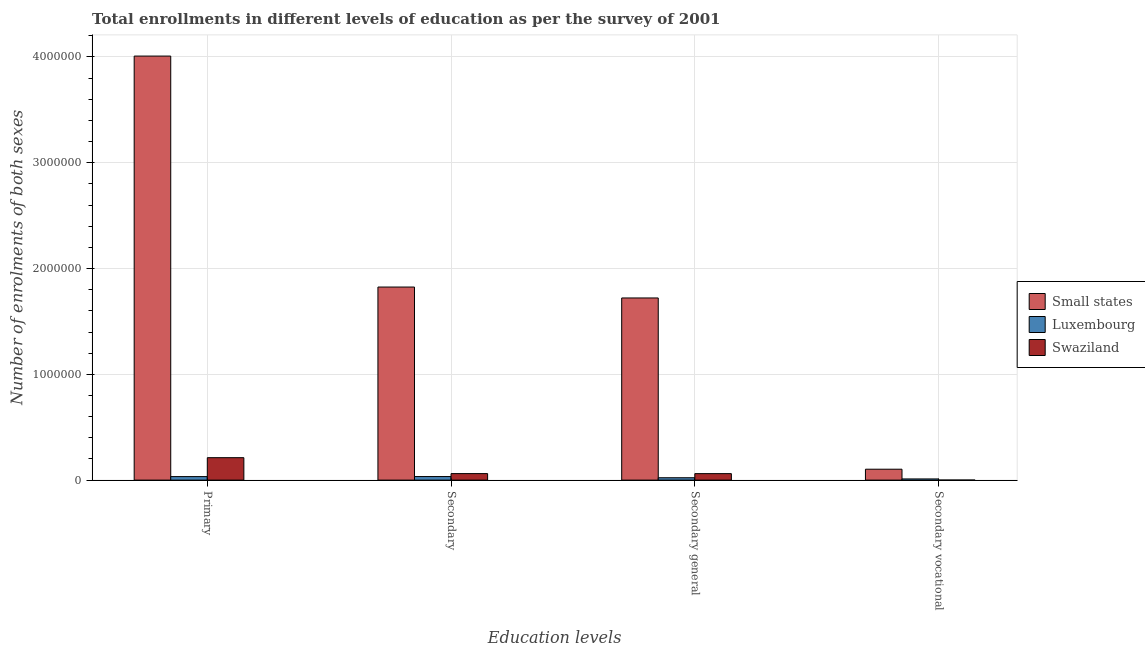How many different coloured bars are there?
Your response must be concise. 3. How many groups of bars are there?
Ensure brevity in your answer.  4. What is the label of the 4th group of bars from the left?
Your answer should be compact. Secondary vocational. What is the number of enrolments in secondary education in Small states?
Provide a succinct answer. 1.83e+06. Across all countries, what is the maximum number of enrolments in secondary education?
Offer a terse response. 1.83e+06. Across all countries, what is the minimum number of enrolments in secondary vocational education?
Offer a very short reply. 348. In which country was the number of enrolments in secondary education maximum?
Make the answer very short. Small states. In which country was the number of enrolments in secondary vocational education minimum?
Your response must be concise. Swaziland. What is the total number of enrolments in secondary education in the graph?
Provide a succinct answer. 1.92e+06. What is the difference between the number of enrolments in secondary education in Small states and that in Swaziland?
Your answer should be compact. 1.76e+06. What is the difference between the number of enrolments in primary education in Luxembourg and the number of enrolments in secondary education in Small states?
Provide a succinct answer. -1.79e+06. What is the average number of enrolments in secondary education per country?
Provide a short and direct response. 6.40e+05. What is the difference between the number of enrolments in primary education and number of enrolments in secondary general education in Swaziland?
Offer a very short reply. 1.51e+05. In how many countries, is the number of enrolments in secondary education greater than 3400000 ?
Offer a terse response. 0. What is the ratio of the number of enrolments in secondary vocational education in Small states to that in Swaziland?
Your answer should be very brief. 296.4. Is the difference between the number of enrolments in primary education in Swaziland and Luxembourg greater than the difference between the number of enrolments in secondary education in Swaziland and Luxembourg?
Provide a succinct answer. Yes. What is the difference between the highest and the second highest number of enrolments in secondary general education?
Your response must be concise. 1.66e+06. What is the difference between the highest and the lowest number of enrolments in primary education?
Keep it short and to the point. 3.98e+06. In how many countries, is the number of enrolments in secondary general education greater than the average number of enrolments in secondary general education taken over all countries?
Your answer should be compact. 1. Is it the case that in every country, the sum of the number of enrolments in secondary general education and number of enrolments in secondary education is greater than the sum of number of enrolments in primary education and number of enrolments in secondary vocational education?
Ensure brevity in your answer.  No. What does the 1st bar from the left in Primary represents?
Offer a terse response. Small states. What does the 3rd bar from the right in Secondary general represents?
Give a very brief answer. Small states. Is it the case that in every country, the sum of the number of enrolments in primary education and number of enrolments in secondary education is greater than the number of enrolments in secondary general education?
Make the answer very short. Yes. How many countries are there in the graph?
Ensure brevity in your answer.  3. What is the difference between two consecutive major ticks on the Y-axis?
Make the answer very short. 1.00e+06. Does the graph contain any zero values?
Provide a short and direct response. No. Does the graph contain grids?
Give a very brief answer. Yes. What is the title of the graph?
Your answer should be very brief. Total enrollments in different levels of education as per the survey of 2001. What is the label or title of the X-axis?
Offer a very short reply. Education levels. What is the label or title of the Y-axis?
Give a very brief answer. Number of enrolments of both sexes. What is the Number of enrolments of both sexes in Small states in Primary?
Give a very brief answer. 4.01e+06. What is the Number of enrolments of both sexes of Luxembourg in Primary?
Offer a very short reply. 3.33e+04. What is the Number of enrolments of both sexes of Swaziland in Primary?
Provide a short and direct response. 2.12e+05. What is the Number of enrolments of both sexes of Small states in Secondary?
Keep it short and to the point. 1.83e+06. What is the Number of enrolments of both sexes of Luxembourg in Secondary?
Provide a succinct answer. 3.36e+04. What is the Number of enrolments of both sexes in Swaziland in Secondary?
Provide a short and direct response. 6.16e+04. What is the Number of enrolments of both sexes of Small states in Secondary general?
Provide a succinct answer. 1.72e+06. What is the Number of enrolments of both sexes of Luxembourg in Secondary general?
Provide a short and direct response. 2.24e+04. What is the Number of enrolments of both sexes of Swaziland in Secondary general?
Provide a succinct answer. 6.13e+04. What is the Number of enrolments of both sexes in Small states in Secondary vocational?
Make the answer very short. 1.03e+05. What is the Number of enrolments of both sexes in Luxembourg in Secondary vocational?
Your answer should be compact. 1.12e+04. What is the Number of enrolments of both sexes of Swaziland in Secondary vocational?
Provide a succinct answer. 348. Across all Education levels, what is the maximum Number of enrolments of both sexes of Small states?
Offer a very short reply. 4.01e+06. Across all Education levels, what is the maximum Number of enrolments of both sexes of Luxembourg?
Your response must be concise. 3.36e+04. Across all Education levels, what is the maximum Number of enrolments of both sexes of Swaziland?
Offer a very short reply. 2.12e+05. Across all Education levels, what is the minimum Number of enrolments of both sexes in Small states?
Give a very brief answer. 1.03e+05. Across all Education levels, what is the minimum Number of enrolments of both sexes in Luxembourg?
Provide a succinct answer. 1.12e+04. Across all Education levels, what is the minimum Number of enrolments of both sexes in Swaziland?
Your response must be concise. 348. What is the total Number of enrolments of both sexes in Small states in the graph?
Provide a short and direct response. 7.66e+06. What is the total Number of enrolments of both sexes of Luxembourg in the graph?
Offer a very short reply. 1.00e+05. What is the total Number of enrolments of both sexes in Swaziland in the graph?
Offer a terse response. 3.35e+05. What is the difference between the Number of enrolments of both sexes in Small states in Primary and that in Secondary?
Ensure brevity in your answer.  2.18e+06. What is the difference between the Number of enrolments of both sexes of Luxembourg in Primary and that in Secondary?
Provide a short and direct response. -340. What is the difference between the Number of enrolments of both sexes of Swaziland in Primary and that in Secondary?
Ensure brevity in your answer.  1.50e+05. What is the difference between the Number of enrolments of both sexes of Small states in Primary and that in Secondary general?
Your response must be concise. 2.29e+06. What is the difference between the Number of enrolments of both sexes of Luxembourg in Primary and that in Secondary general?
Make the answer very short. 1.08e+04. What is the difference between the Number of enrolments of both sexes in Swaziland in Primary and that in Secondary general?
Ensure brevity in your answer.  1.51e+05. What is the difference between the Number of enrolments of both sexes of Small states in Primary and that in Secondary vocational?
Offer a very short reply. 3.91e+06. What is the difference between the Number of enrolments of both sexes of Luxembourg in Primary and that in Secondary vocational?
Make the answer very short. 2.21e+04. What is the difference between the Number of enrolments of both sexes in Swaziland in Primary and that in Secondary vocational?
Keep it short and to the point. 2.12e+05. What is the difference between the Number of enrolments of both sexes of Small states in Secondary and that in Secondary general?
Your response must be concise. 1.03e+05. What is the difference between the Number of enrolments of both sexes of Luxembourg in Secondary and that in Secondary general?
Your answer should be very brief. 1.12e+04. What is the difference between the Number of enrolments of both sexes in Swaziland in Secondary and that in Secondary general?
Offer a terse response. 348. What is the difference between the Number of enrolments of both sexes of Small states in Secondary and that in Secondary vocational?
Offer a very short reply. 1.72e+06. What is the difference between the Number of enrolments of both sexes in Luxembourg in Secondary and that in Secondary vocational?
Your answer should be compact. 2.24e+04. What is the difference between the Number of enrolments of both sexes in Swaziland in Secondary and that in Secondary vocational?
Provide a short and direct response. 6.13e+04. What is the difference between the Number of enrolments of both sexes in Small states in Secondary general and that in Secondary vocational?
Give a very brief answer. 1.62e+06. What is the difference between the Number of enrolments of both sexes of Luxembourg in Secondary general and that in Secondary vocational?
Your response must be concise. 1.13e+04. What is the difference between the Number of enrolments of both sexes in Swaziland in Secondary general and that in Secondary vocational?
Offer a very short reply. 6.09e+04. What is the difference between the Number of enrolments of both sexes in Small states in Primary and the Number of enrolments of both sexes in Luxembourg in Secondary?
Your answer should be very brief. 3.97e+06. What is the difference between the Number of enrolments of both sexes of Small states in Primary and the Number of enrolments of both sexes of Swaziland in Secondary?
Your answer should be compact. 3.95e+06. What is the difference between the Number of enrolments of both sexes in Luxembourg in Primary and the Number of enrolments of both sexes in Swaziland in Secondary?
Your response must be concise. -2.84e+04. What is the difference between the Number of enrolments of both sexes of Small states in Primary and the Number of enrolments of both sexes of Luxembourg in Secondary general?
Offer a very short reply. 3.99e+06. What is the difference between the Number of enrolments of both sexes of Small states in Primary and the Number of enrolments of both sexes of Swaziland in Secondary general?
Your answer should be compact. 3.95e+06. What is the difference between the Number of enrolments of both sexes of Luxembourg in Primary and the Number of enrolments of both sexes of Swaziland in Secondary general?
Provide a short and direct response. -2.80e+04. What is the difference between the Number of enrolments of both sexes in Small states in Primary and the Number of enrolments of both sexes in Luxembourg in Secondary vocational?
Offer a very short reply. 4.00e+06. What is the difference between the Number of enrolments of both sexes of Small states in Primary and the Number of enrolments of both sexes of Swaziland in Secondary vocational?
Make the answer very short. 4.01e+06. What is the difference between the Number of enrolments of both sexes of Luxembourg in Primary and the Number of enrolments of both sexes of Swaziland in Secondary vocational?
Keep it short and to the point. 3.29e+04. What is the difference between the Number of enrolments of both sexes in Small states in Secondary and the Number of enrolments of both sexes in Luxembourg in Secondary general?
Your answer should be very brief. 1.80e+06. What is the difference between the Number of enrolments of both sexes of Small states in Secondary and the Number of enrolments of both sexes of Swaziland in Secondary general?
Provide a short and direct response. 1.76e+06. What is the difference between the Number of enrolments of both sexes of Luxembourg in Secondary and the Number of enrolments of both sexes of Swaziland in Secondary general?
Give a very brief answer. -2.77e+04. What is the difference between the Number of enrolments of both sexes of Small states in Secondary and the Number of enrolments of both sexes of Luxembourg in Secondary vocational?
Offer a very short reply. 1.81e+06. What is the difference between the Number of enrolments of both sexes of Small states in Secondary and the Number of enrolments of both sexes of Swaziland in Secondary vocational?
Provide a succinct answer. 1.82e+06. What is the difference between the Number of enrolments of both sexes in Luxembourg in Secondary and the Number of enrolments of both sexes in Swaziland in Secondary vocational?
Provide a short and direct response. 3.33e+04. What is the difference between the Number of enrolments of both sexes in Small states in Secondary general and the Number of enrolments of both sexes in Luxembourg in Secondary vocational?
Your answer should be compact. 1.71e+06. What is the difference between the Number of enrolments of both sexes of Small states in Secondary general and the Number of enrolments of both sexes of Swaziland in Secondary vocational?
Your answer should be very brief. 1.72e+06. What is the difference between the Number of enrolments of both sexes of Luxembourg in Secondary general and the Number of enrolments of both sexes of Swaziland in Secondary vocational?
Keep it short and to the point. 2.21e+04. What is the average Number of enrolments of both sexes in Small states per Education levels?
Offer a terse response. 1.91e+06. What is the average Number of enrolments of both sexes of Luxembourg per Education levels?
Your response must be concise. 2.51e+04. What is the average Number of enrolments of both sexes of Swaziland per Education levels?
Your answer should be compact. 8.38e+04. What is the difference between the Number of enrolments of both sexes of Small states and Number of enrolments of both sexes of Luxembourg in Primary?
Provide a succinct answer. 3.98e+06. What is the difference between the Number of enrolments of both sexes of Small states and Number of enrolments of both sexes of Swaziland in Primary?
Provide a short and direct response. 3.80e+06. What is the difference between the Number of enrolments of both sexes in Luxembourg and Number of enrolments of both sexes in Swaziland in Primary?
Provide a short and direct response. -1.79e+05. What is the difference between the Number of enrolments of both sexes of Small states and Number of enrolments of both sexes of Luxembourg in Secondary?
Offer a very short reply. 1.79e+06. What is the difference between the Number of enrolments of both sexes of Small states and Number of enrolments of both sexes of Swaziland in Secondary?
Make the answer very short. 1.76e+06. What is the difference between the Number of enrolments of both sexes of Luxembourg and Number of enrolments of both sexes of Swaziland in Secondary?
Provide a short and direct response. -2.80e+04. What is the difference between the Number of enrolments of both sexes in Small states and Number of enrolments of both sexes in Luxembourg in Secondary general?
Ensure brevity in your answer.  1.70e+06. What is the difference between the Number of enrolments of both sexes in Small states and Number of enrolments of both sexes in Swaziland in Secondary general?
Your answer should be compact. 1.66e+06. What is the difference between the Number of enrolments of both sexes in Luxembourg and Number of enrolments of both sexes in Swaziland in Secondary general?
Provide a short and direct response. -3.88e+04. What is the difference between the Number of enrolments of both sexes of Small states and Number of enrolments of both sexes of Luxembourg in Secondary vocational?
Your answer should be compact. 9.20e+04. What is the difference between the Number of enrolments of both sexes in Small states and Number of enrolments of both sexes in Swaziland in Secondary vocational?
Your response must be concise. 1.03e+05. What is the difference between the Number of enrolments of both sexes of Luxembourg and Number of enrolments of both sexes of Swaziland in Secondary vocational?
Ensure brevity in your answer.  1.08e+04. What is the ratio of the Number of enrolments of both sexes of Small states in Primary to that in Secondary?
Give a very brief answer. 2.2. What is the ratio of the Number of enrolments of both sexes in Luxembourg in Primary to that in Secondary?
Provide a succinct answer. 0.99. What is the ratio of the Number of enrolments of both sexes in Swaziland in Primary to that in Secondary?
Ensure brevity in your answer.  3.44. What is the ratio of the Number of enrolments of both sexes of Small states in Primary to that in Secondary general?
Ensure brevity in your answer.  2.33. What is the ratio of the Number of enrolments of both sexes of Luxembourg in Primary to that in Secondary general?
Your answer should be very brief. 1.48. What is the ratio of the Number of enrolments of both sexes of Swaziland in Primary to that in Secondary general?
Offer a very short reply. 3.46. What is the ratio of the Number of enrolments of both sexes of Small states in Primary to that in Secondary vocational?
Offer a very short reply. 38.86. What is the ratio of the Number of enrolments of both sexes of Luxembourg in Primary to that in Secondary vocational?
Give a very brief answer. 2.98. What is the ratio of the Number of enrolments of both sexes of Swaziland in Primary to that in Secondary vocational?
Provide a succinct answer. 609.38. What is the ratio of the Number of enrolments of both sexes in Small states in Secondary to that in Secondary general?
Your answer should be very brief. 1.06. What is the ratio of the Number of enrolments of both sexes of Luxembourg in Secondary to that in Secondary general?
Your response must be concise. 1.5. What is the ratio of the Number of enrolments of both sexes in Swaziland in Secondary to that in Secondary general?
Keep it short and to the point. 1.01. What is the ratio of the Number of enrolments of both sexes of Small states in Secondary to that in Secondary vocational?
Give a very brief answer. 17.69. What is the ratio of the Number of enrolments of both sexes in Luxembourg in Secondary to that in Secondary vocational?
Provide a short and direct response. 3.01. What is the ratio of the Number of enrolments of both sexes in Swaziland in Secondary to that in Secondary vocational?
Your answer should be very brief. 177.08. What is the ratio of the Number of enrolments of both sexes of Small states in Secondary general to that in Secondary vocational?
Your answer should be compact. 16.69. What is the ratio of the Number of enrolments of both sexes in Luxembourg in Secondary general to that in Secondary vocational?
Your answer should be very brief. 2.01. What is the ratio of the Number of enrolments of both sexes in Swaziland in Secondary general to that in Secondary vocational?
Provide a succinct answer. 176.08. What is the difference between the highest and the second highest Number of enrolments of both sexes of Small states?
Keep it short and to the point. 2.18e+06. What is the difference between the highest and the second highest Number of enrolments of both sexes of Luxembourg?
Provide a short and direct response. 340. What is the difference between the highest and the second highest Number of enrolments of both sexes in Swaziland?
Provide a succinct answer. 1.50e+05. What is the difference between the highest and the lowest Number of enrolments of both sexes of Small states?
Provide a short and direct response. 3.91e+06. What is the difference between the highest and the lowest Number of enrolments of both sexes of Luxembourg?
Offer a terse response. 2.24e+04. What is the difference between the highest and the lowest Number of enrolments of both sexes of Swaziland?
Offer a terse response. 2.12e+05. 